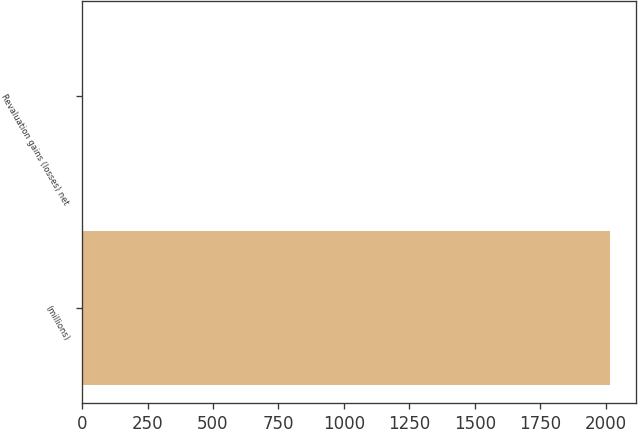Convert chart to OTSL. <chart><loc_0><loc_0><loc_500><loc_500><bar_chart><fcel>(millions)<fcel>Revaluation gains (losses) net<nl><fcel>2016<fcel>2.5<nl></chart> 